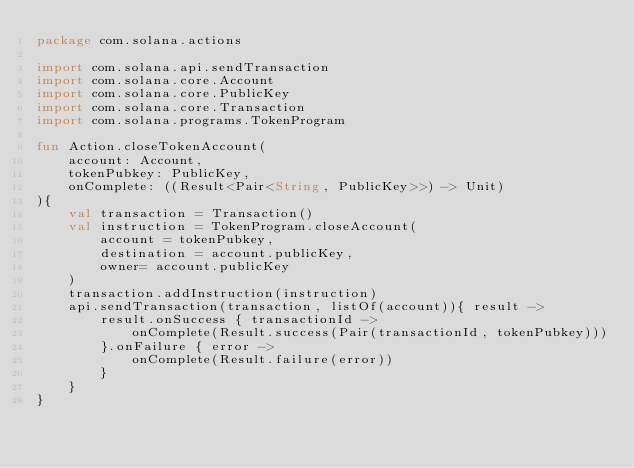Convert code to text. <code><loc_0><loc_0><loc_500><loc_500><_Kotlin_>package com.solana.actions

import com.solana.api.sendTransaction
import com.solana.core.Account
import com.solana.core.PublicKey
import com.solana.core.Transaction
import com.solana.programs.TokenProgram

fun Action.closeTokenAccount(
    account: Account,
    tokenPubkey: PublicKey,
    onComplete: ((Result<Pair<String, PublicKey>>) -> Unit)
){
    val transaction = Transaction()
    val instruction = TokenProgram.closeAccount(
        account = tokenPubkey,
        destination = account.publicKey,
        owner= account.publicKey
    )
    transaction.addInstruction(instruction)
    api.sendTransaction(transaction, listOf(account)){ result ->
        result.onSuccess { transactionId ->
            onComplete(Result.success(Pair(transactionId, tokenPubkey)))
        }.onFailure { error ->
            onComplete(Result.failure(error))
        }
    }
}</code> 